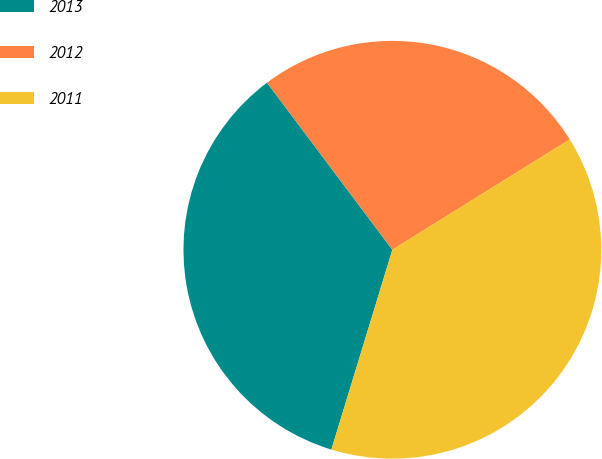Convert chart. <chart><loc_0><loc_0><loc_500><loc_500><pie_chart><fcel>2013<fcel>2012<fcel>2011<nl><fcel>35.04%<fcel>26.39%<fcel>38.57%<nl></chart> 